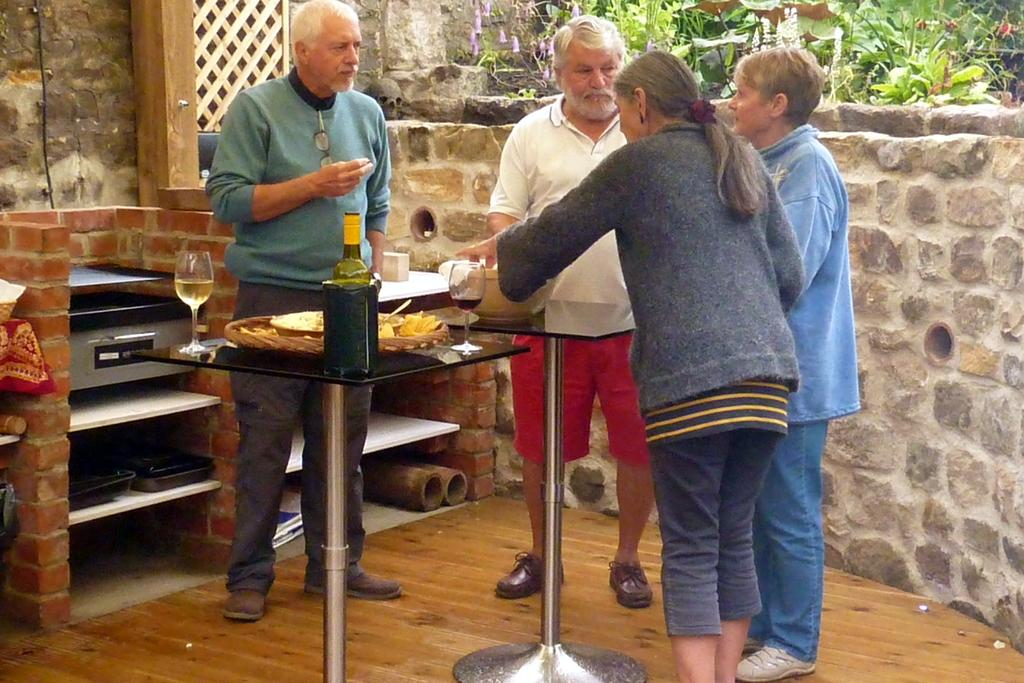How many persons are in the image? There are four persons standing in the image. What type of furniture can be seen in the image? There are tables in the image. What is the bottle likely to contain? The bottle might contain a liquid, such as water or juice. What are the glasses with liquid used for? The glasses with liquid are likely used for drinking. What is in the bowl? There is a bowl in the image, but the contents are not specified. What appliance is present in the image? There is a stove in the image. What type of storage is available in the image? There are shelves in the image for storage. What is the background of the image made of? There is a wall in the image, which is likely made of brick, concrete, or another solid material. What type of vegetation is present in the image? There are plants in the image. Can you describe any other objects in the image? There are other objects in the image, but their specific nature is not mentioned. What type of writing can be seen on the wall in the image? There is no writing visible on the wall in the image. How does the stove stop working in the image? The stove does not stop working in the image; it is functioning as expected. What type of sugar is present in the image? There is no sugar present in the image. 